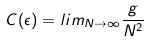Convert formula to latex. <formula><loc_0><loc_0><loc_500><loc_500>C ( \epsilon ) = l i m _ { N \rightarrow \infty } \frac { g } { N ^ { 2 } }</formula> 